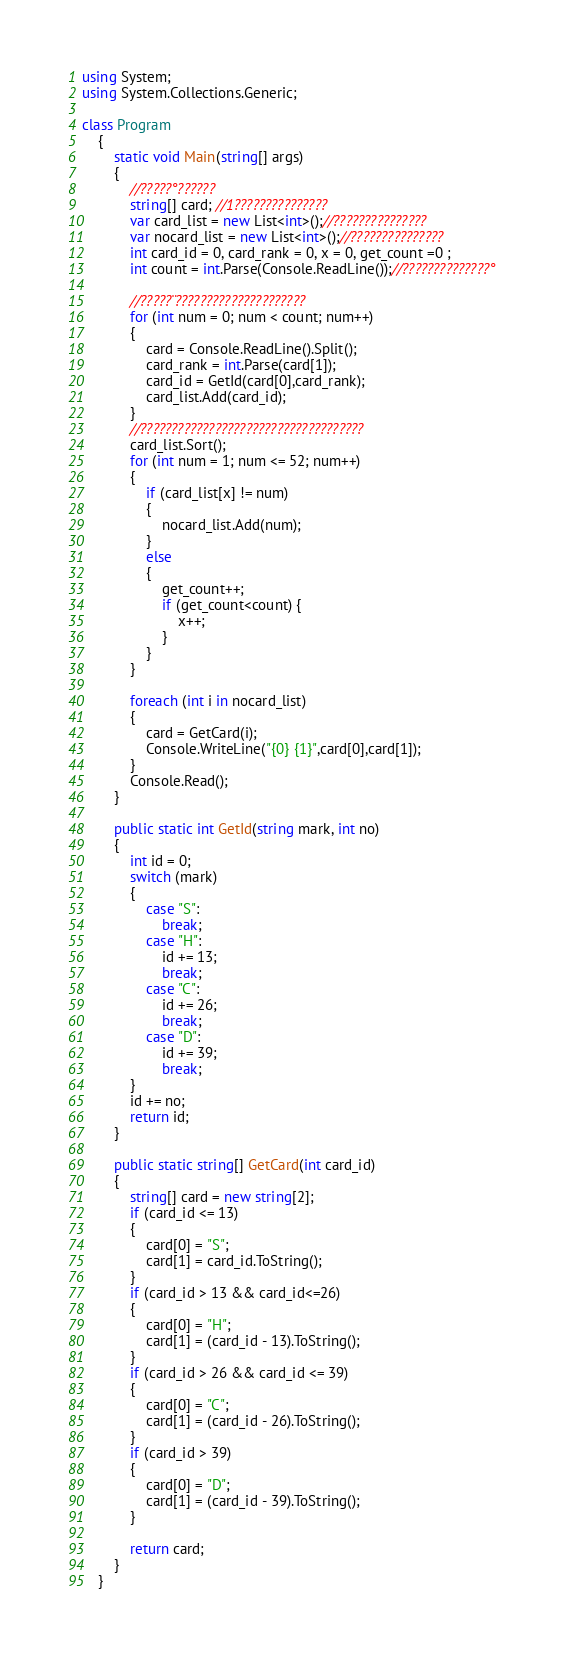Convert code to text. <code><loc_0><loc_0><loc_500><loc_500><_C#_>using System;
using System.Collections.Generic;

class Program
    {
        static void Main(string[] args)
        {
            //?????°??????
            string[] card; //1???????????????
            var card_list = new List<int>();//???????????????
            var nocard_list = new List<int>();//???????????????
            int card_id = 0, card_rank = 0, x = 0, get_count =0 ;
            int count = int.Parse(Console.ReadLine());//??????????????°

            //?????¨?????????????????????
            for (int num = 0; num < count; num++)
            {
                card = Console.ReadLine().Split();
                card_rank = int.Parse(card[1]);
                card_id = GetId(card[0],card_rank);
                card_list.Add(card_id);
            }
            //????????????????????????????????????
            card_list.Sort();
            for (int num = 1; num <= 52; num++)
            {               
                if (card_list[x] != num)
                {
                    nocard_list.Add(num);
                }
                else
                {
                    get_count++;
                    if (get_count<count) {
                        x++;
                    }
                }
            }

            foreach (int i in nocard_list)
            {
                card = GetCard(i);
                Console.WriteLine("{0} {1}",card[0],card[1]);
            }
            Console.Read();
        }

        public static int GetId(string mark, int no)
        {
            int id = 0;
            switch (mark)
            {
                case "S":
                    break;
                case "H":
                    id += 13;
                    break;
                case "C":
                    id += 26;
                    break;
                case "D":
                    id += 39;
                    break;
            }
            id += no;
            return id;
        }

        public static string[] GetCard(int card_id)
        {
            string[] card = new string[2];
            if (card_id <= 13)
            {
                card[0] = "S";
                card[1] = card_id.ToString();
            }
            if (card_id > 13 && card_id<=26)
            {
                card[0] = "H";
                card[1] = (card_id - 13).ToString();
            }
            if (card_id > 26 && card_id <= 39)
            {
                card[0] = "C";
                card[1] = (card_id - 26).ToString();
            }
            if (card_id > 39)
            {
                card[0] = "D";
                card[1] = (card_id - 39).ToString();
            }

            return card;
        }
    }</code> 